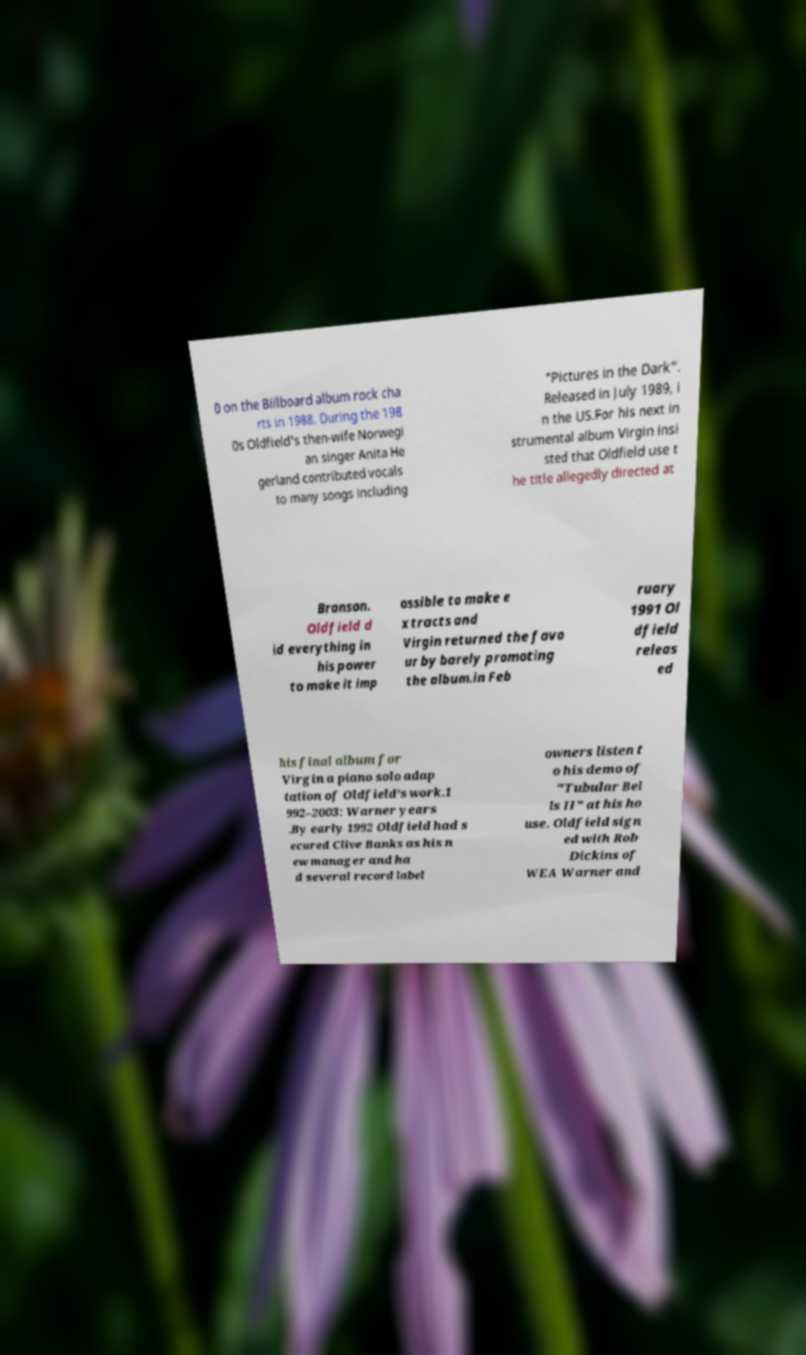There's text embedded in this image that I need extracted. Can you transcribe it verbatim? 0 on the Billboard album rock cha rts in 1988. During the 198 0s Oldfield's then-wife Norwegi an singer Anita He gerland contributed vocals to many songs including "Pictures in the Dark". Released in July 1989, i n the US.For his next in strumental album Virgin insi sted that Oldfield use t he title allegedly directed at Branson. Oldfield d id everything in his power to make it imp ossible to make e xtracts and Virgin returned the favo ur by barely promoting the album.in Feb ruary 1991 Ol dfield releas ed his final album for Virgin a piano solo adap tation of Oldfield's work.1 992–2003: Warner years .By early 1992 Oldfield had s ecured Clive Banks as his n ew manager and ha d several record label owners listen t o his demo of "Tubular Bel ls II" at his ho use. Oldfield sign ed with Rob Dickins of WEA Warner and 